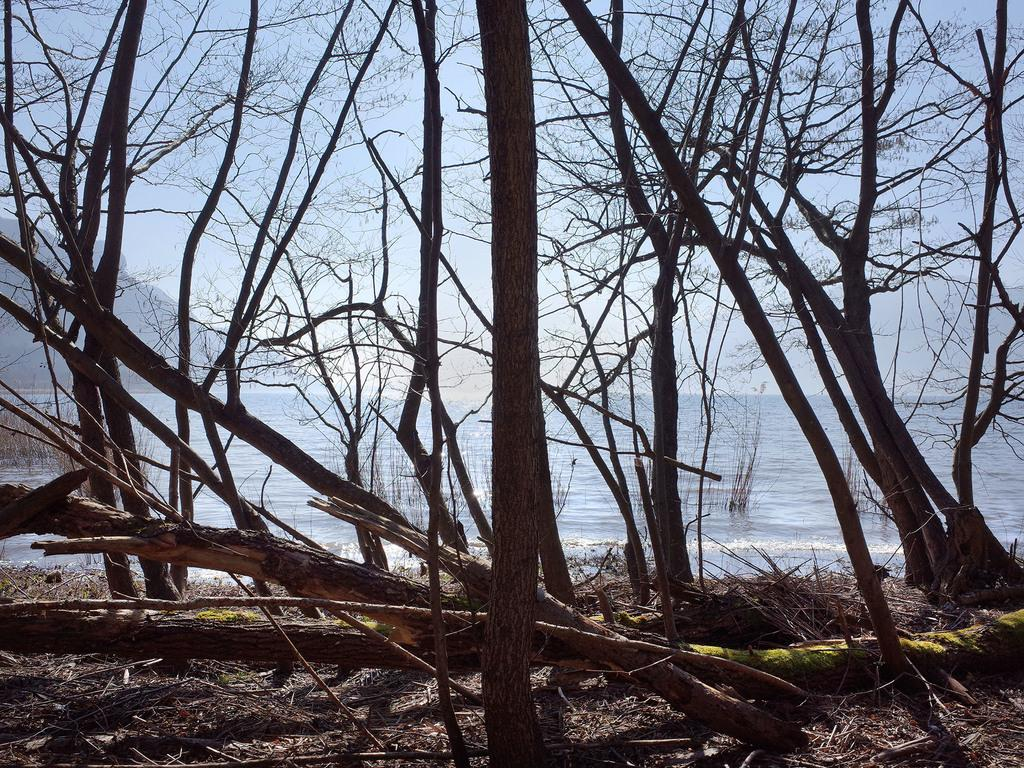What is located in the middle of the image? There are trees and water in the middle of the image. What can be seen at the top of the image? The sky is visible at the top of the image. What is the value of the square kitty in the image? There is no square kitty present in the image, and therefore no value can be assigned to it. 